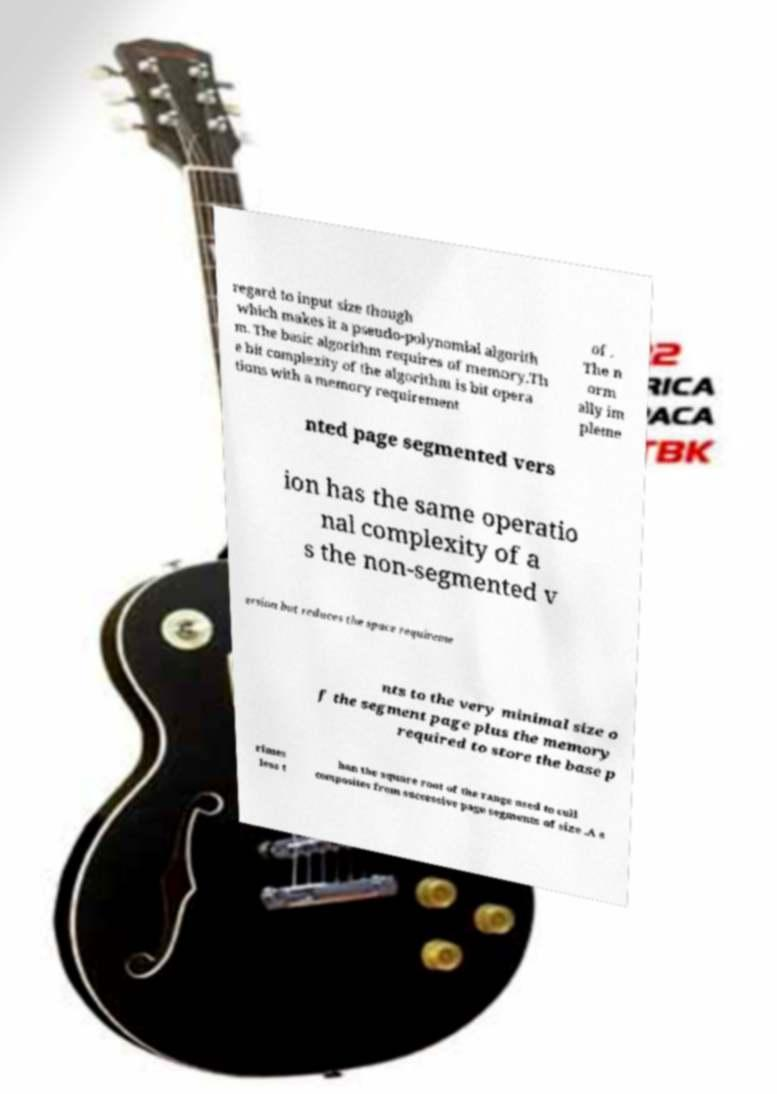Can you accurately transcribe the text from the provided image for me? regard to input size though which makes it a pseudo-polynomial algorith m. The basic algorithm requires of memory.Th e bit complexity of the algorithm is bit opera tions with a memory requirement of . The n orm ally im pleme nted page segmented vers ion has the same operatio nal complexity of a s the non-segmented v ersion but reduces the space requireme nts to the very minimal size o f the segment page plus the memory required to store the base p rimes less t han the square root of the range used to cull composites from successive page segments of size .A s 